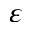Convert formula to latex. <formula><loc_0><loc_0><loc_500><loc_500>\varepsilon</formula> 